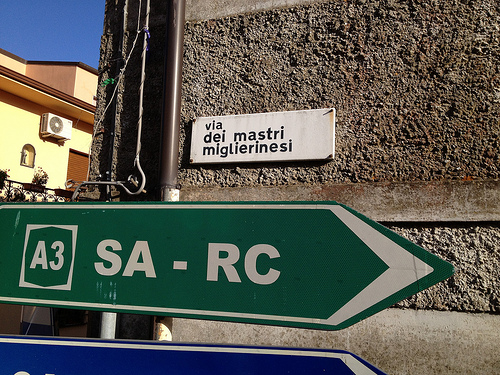Can you tell me what the street name sign says? Certainly, the street sign reads 'via dei mastri migliori nesi,' which translates to 'Street of the Master Craftsmen' in English.  How would you describe the overall setting of this location? The setting appears to be an urban residential or commercial area during daylight hours. The visibility of signage, such as the street name and directional road signs, suggests a well-organized and possibly high-traffic area. 